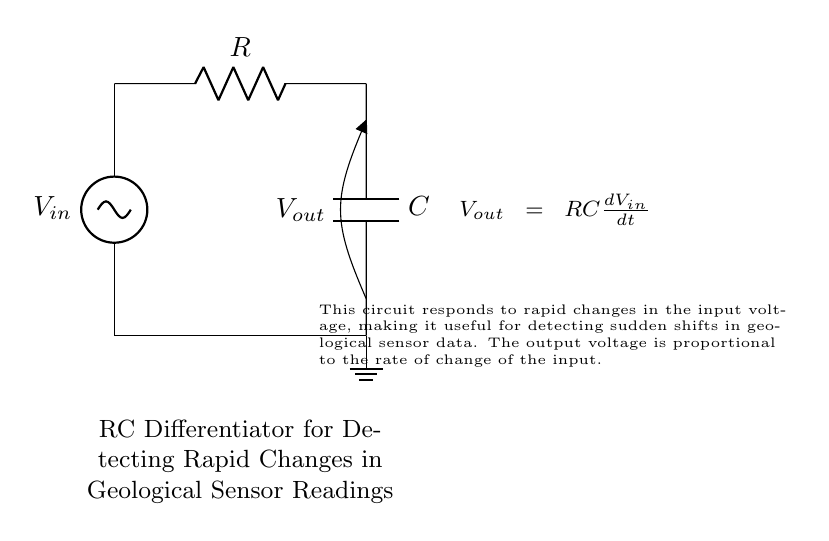What is the input voltage in this circuit? The input voltage is represented by the symbol \(V_{in}\) in the circuit diagram. However, the specific value is not provided; it's a general variable indicating the supply or signal voltage applied to the circuit.
Answer: \(V_{in}\) What type of capacitor is used in this circuit? The circuit diagram does not specify the type of capacitor; it only labels the component as \(C\). Capacitors can vary in type (such as ceramic, electrolytic, etc.), but this information is not presented in the diagram.
Answer: Capacitor \(C\) What is the role of the resistor in this circuit? The resistor labeled \(R\) serves to control the time constant of the circuit (\(RC\)), which affects how quickly the capacitor charges and discharges, thus influencing the output voltage response to changes in the input voltage.
Answer: Control time constant How does the output voltage relate to the input voltage changes? The output voltage \(V_{out}\) is directly related to the rate of change of the input voltage as described by the equation \(V_{out} = RC\frac{dV_{in}}{dt}\). This means that any rapid changes in \(V_{in}\) will produce a proportional \(V_{out}\).
Answer: Proportional to rate of change What does the ground in the circuit signify? The ground denotes a common reference point in the circuit, which is usually set to zero volts. It establishes a return path for the electrical current, ensuring that the circuit operates correctly.
Answer: Zero volts reference What is the main application of this RC differentiator circuit? This circuit is specifically designed to detect rapid changes in geological sensor readings, making it useful in applications requiring quick response to environmental shifts.
Answer: Detecting rapid changes 